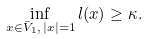Convert formula to latex. <formula><loc_0><loc_0><loc_500><loc_500>\inf _ { x \in \bar { V } _ { 1 } , \, | x | = 1 } l ( x ) \geq \kappa .</formula> 